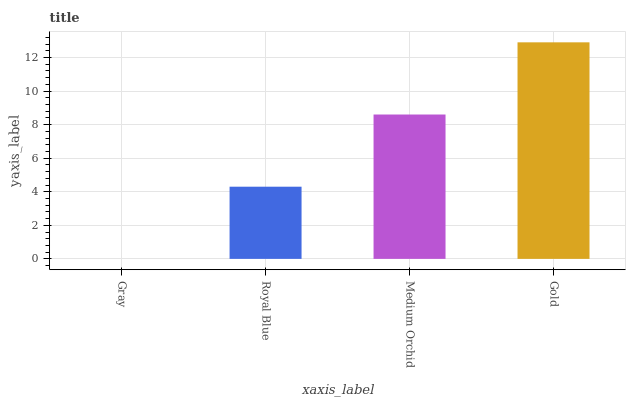Is Royal Blue the minimum?
Answer yes or no. No. Is Royal Blue the maximum?
Answer yes or no. No. Is Royal Blue greater than Gray?
Answer yes or no. Yes. Is Gray less than Royal Blue?
Answer yes or no. Yes. Is Gray greater than Royal Blue?
Answer yes or no. No. Is Royal Blue less than Gray?
Answer yes or no. No. Is Medium Orchid the high median?
Answer yes or no. Yes. Is Royal Blue the low median?
Answer yes or no. Yes. Is Gray the high median?
Answer yes or no. No. Is Medium Orchid the low median?
Answer yes or no. No. 